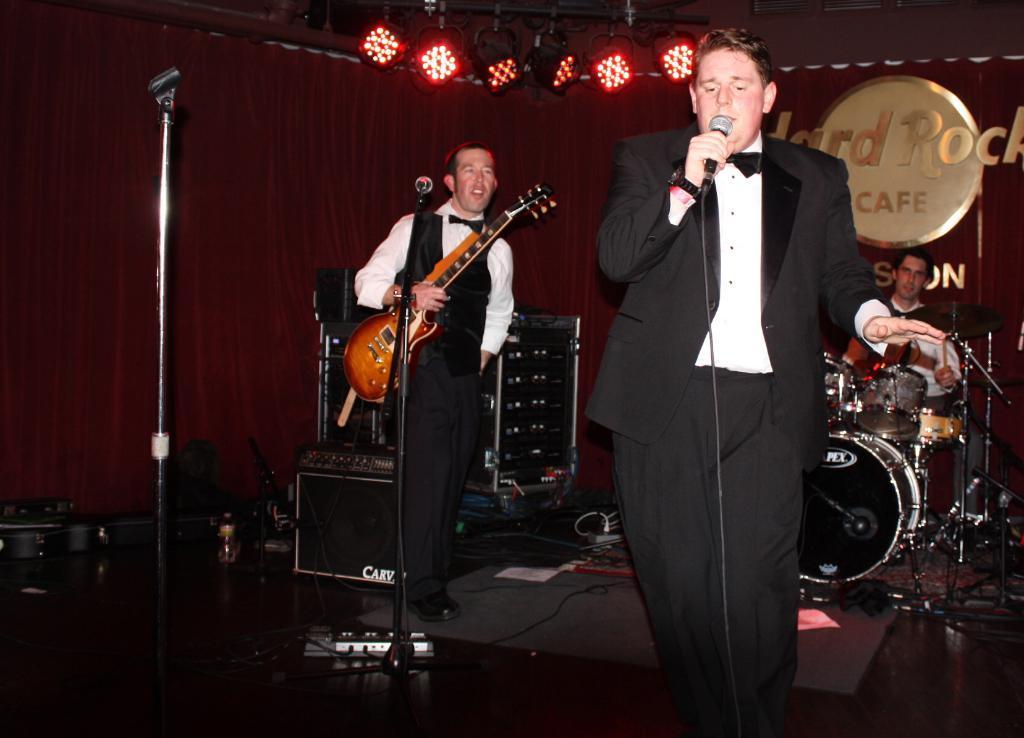Can you describe this image briefly? In this image, In the right side there is a man standing and he is holding a microphone which is in black color and he is singing in the microphone, in the middle there is a man standing and holding a music instrument which is in yellow color, There are some microphones which are in black color, In the background there is a man's sitting and he is playing some music instruments, In the background there are some red color lights in the top and there is a red color curtain. 